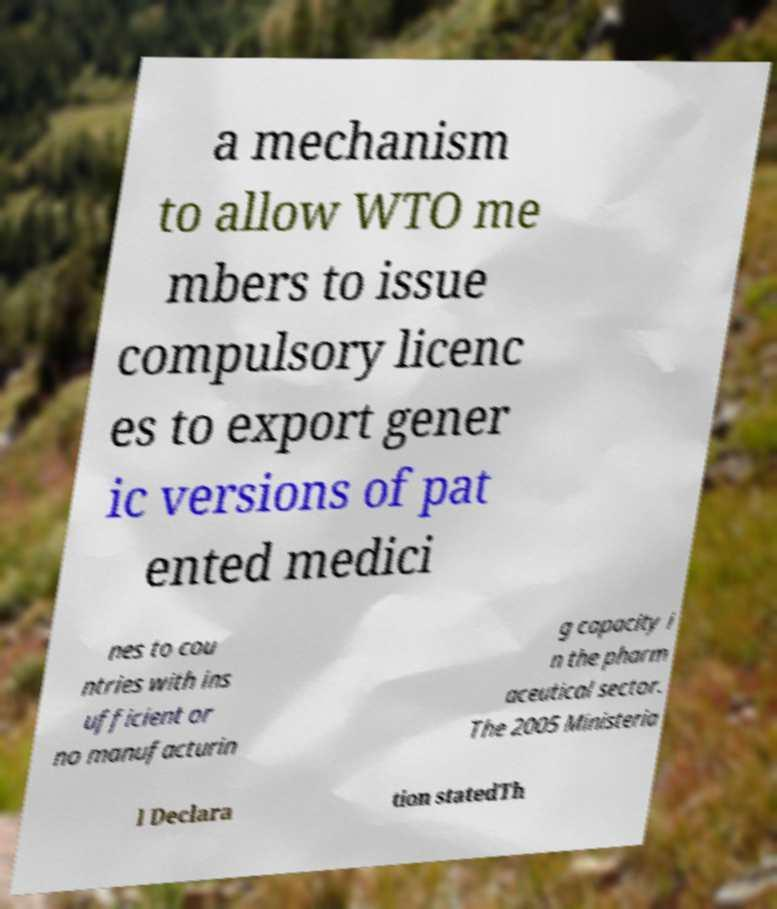Could you assist in decoding the text presented in this image and type it out clearly? a mechanism to allow WTO me mbers to issue compulsory licenc es to export gener ic versions of pat ented medici nes to cou ntries with ins ufficient or no manufacturin g capacity i n the pharm aceutical sector. The 2005 Ministeria l Declara tion statedTh 